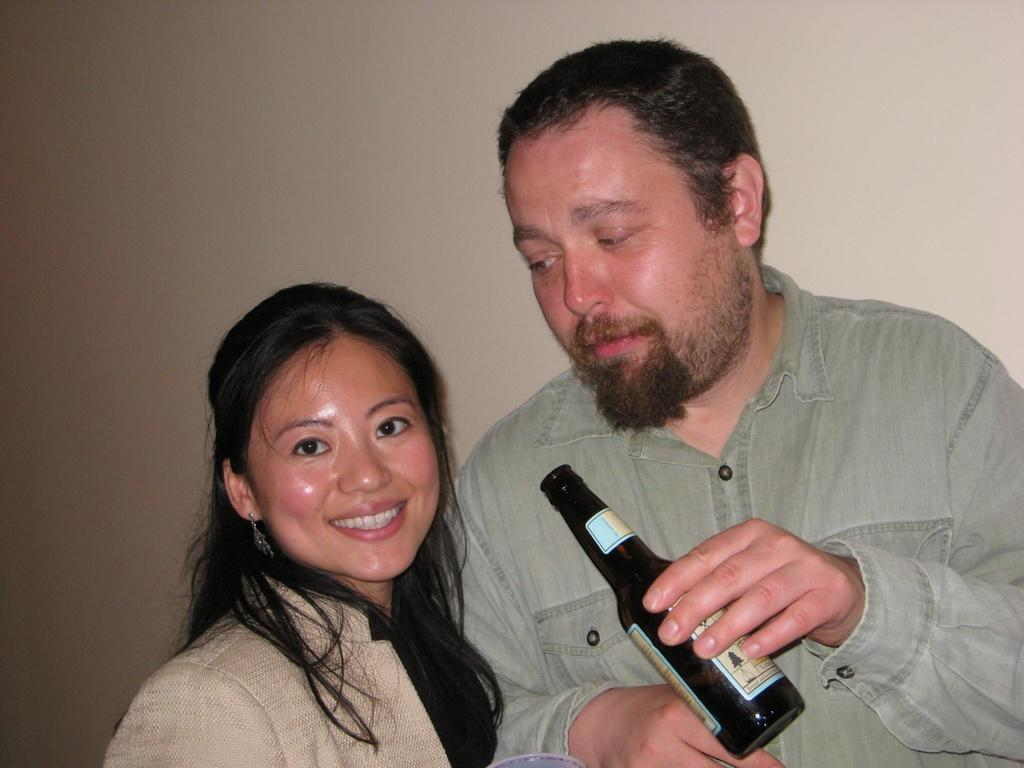What can be seen in the background of the image? There is a wall in the background of the image. Who is present in the image? There is a man and a woman in the image. What is the man holding in his hand? The man is holding a bottle in his hand. How is the woman depicted in the image? The woman is carrying a beautiful smile on her face. How many tomatoes are on the wall in the image? There are no tomatoes present on the wall in the image. Is there a guide in the image to help the man and woman navigate? There is no guide present in the image. 